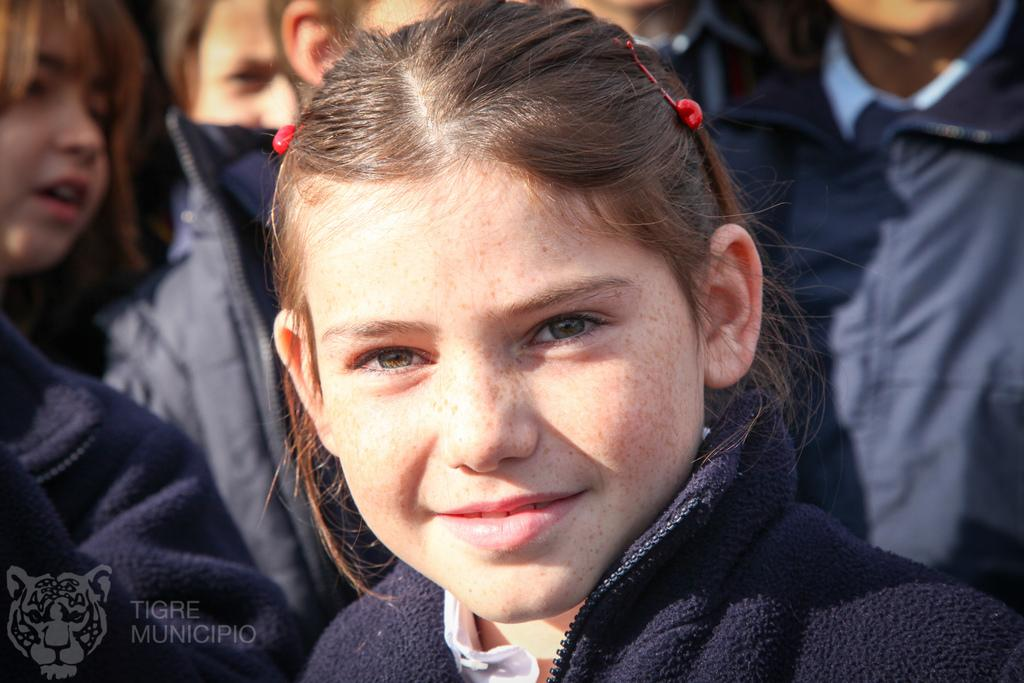Who is the main subject in the image? There is a girl in the image. Where is the girl positioned in relation to the other subjects? The girl is standing in the front. What is the girl wearing in the image? The girl is wearing a black sweatshirt. Can you describe the other subjects in the image? There are many girls standing in the background. What type of shelf can be seen in the image? There is no shelf present in the image. 